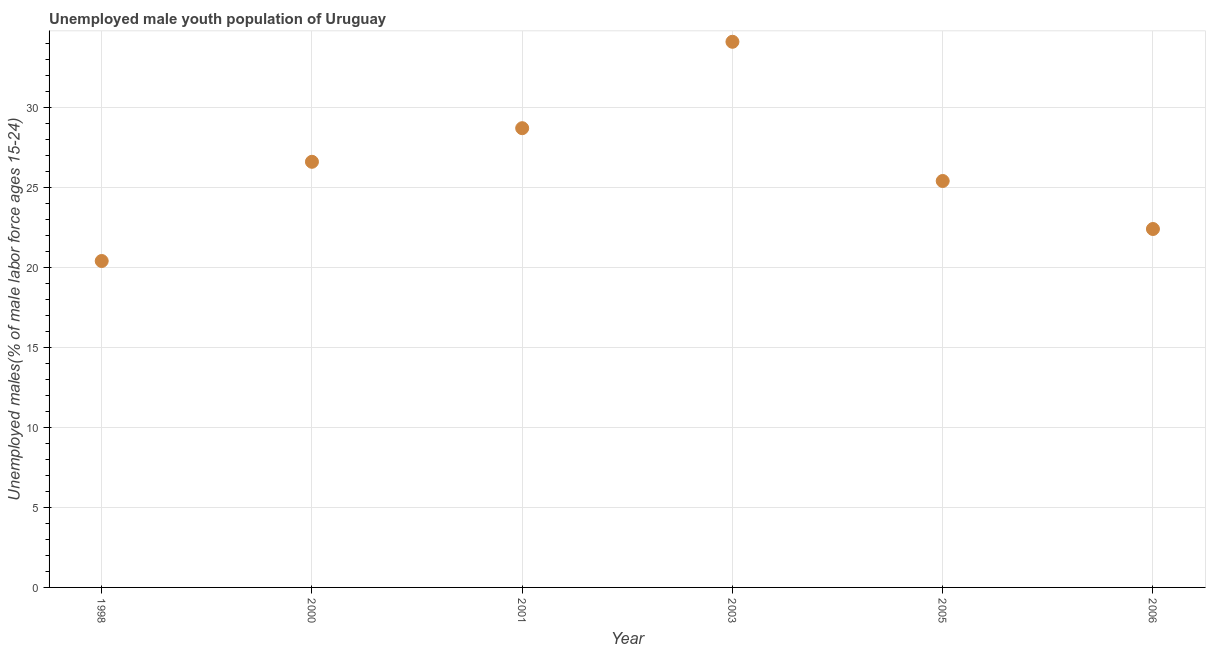What is the unemployed male youth in 2001?
Give a very brief answer. 28.7. Across all years, what is the maximum unemployed male youth?
Give a very brief answer. 34.1. Across all years, what is the minimum unemployed male youth?
Make the answer very short. 20.4. In which year was the unemployed male youth maximum?
Give a very brief answer. 2003. In which year was the unemployed male youth minimum?
Keep it short and to the point. 1998. What is the sum of the unemployed male youth?
Provide a succinct answer. 157.6. What is the difference between the unemployed male youth in 1998 and 2001?
Make the answer very short. -8.3. What is the average unemployed male youth per year?
Your answer should be very brief. 26.27. What is the ratio of the unemployed male youth in 1998 to that in 2001?
Your answer should be very brief. 0.71. What is the difference between the highest and the second highest unemployed male youth?
Give a very brief answer. 5.4. What is the difference between the highest and the lowest unemployed male youth?
Your answer should be very brief. 13.7. Does the unemployed male youth monotonically increase over the years?
Give a very brief answer. No. How many dotlines are there?
Make the answer very short. 1. How many years are there in the graph?
Your answer should be very brief. 6. Does the graph contain grids?
Keep it short and to the point. Yes. What is the title of the graph?
Provide a short and direct response. Unemployed male youth population of Uruguay. What is the label or title of the Y-axis?
Provide a succinct answer. Unemployed males(% of male labor force ages 15-24). What is the Unemployed males(% of male labor force ages 15-24) in 1998?
Keep it short and to the point. 20.4. What is the Unemployed males(% of male labor force ages 15-24) in 2000?
Provide a short and direct response. 26.6. What is the Unemployed males(% of male labor force ages 15-24) in 2001?
Provide a short and direct response. 28.7. What is the Unemployed males(% of male labor force ages 15-24) in 2003?
Provide a succinct answer. 34.1. What is the Unemployed males(% of male labor force ages 15-24) in 2005?
Your response must be concise. 25.4. What is the Unemployed males(% of male labor force ages 15-24) in 2006?
Your answer should be very brief. 22.4. What is the difference between the Unemployed males(% of male labor force ages 15-24) in 1998 and 2000?
Provide a short and direct response. -6.2. What is the difference between the Unemployed males(% of male labor force ages 15-24) in 1998 and 2003?
Offer a very short reply. -13.7. What is the difference between the Unemployed males(% of male labor force ages 15-24) in 1998 and 2005?
Provide a short and direct response. -5. What is the difference between the Unemployed males(% of male labor force ages 15-24) in 1998 and 2006?
Your answer should be compact. -2. What is the difference between the Unemployed males(% of male labor force ages 15-24) in 2000 and 2003?
Ensure brevity in your answer.  -7.5. What is the difference between the Unemployed males(% of male labor force ages 15-24) in 2000 and 2005?
Ensure brevity in your answer.  1.2. What is the difference between the Unemployed males(% of male labor force ages 15-24) in 2000 and 2006?
Give a very brief answer. 4.2. What is the difference between the Unemployed males(% of male labor force ages 15-24) in 2001 and 2003?
Ensure brevity in your answer.  -5.4. What is the difference between the Unemployed males(% of male labor force ages 15-24) in 2001 and 2005?
Give a very brief answer. 3.3. What is the difference between the Unemployed males(% of male labor force ages 15-24) in 2001 and 2006?
Give a very brief answer. 6.3. What is the difference between the Unemployed males(% of male labor force ages 15-24) in 2005 and 2006?
Provide a short and direct response. 3. What is the ratio of the Unemployed males(% of male labor force ages 15-24) in 1998 to that in 2000?
Your response must be concise. 0.77. What is the ratio of the Unemployed males(% of male labor force ages 15-24) in 1998 to that in 2001?
Make the answer very short. 0.71. What is the ratio of the Unemployed males(% of male labor force ages 15-24) in 1998 to that in 2003?
Your answer should be compact. 0.6. What is the ratio of the Unemployed males(% of male labor force ages 15-24) in 1998 to that in 2005?
Provide a short and direct response. 0.8. What is the ratio of the Unemployed males(% of male labor force ages 15-24) in 1998 to that in 2006?
Your response must be concise. 0.91. What is the ratio of the Unemployed males(% of male labor force ages 15-24) in 2000 to that in 2001?
Provide a short and direct response. 0.93. What is the ratio of the Unemployed males(% of male labor force ages 15-24) in 2000 to that in 2003?
Your response must be concise. 0.78. What is the ratio of the Unemployed males(% of male labor force ages 15-24) in 2000 to that in 2005?
Offer a very short reply. 1.05. What is the ratio of the Unemployed males(% of male labor force ages 15-24) in 2000 to that in 2006?
Make the answer very short. 1.19. What is the ratio of the Unemployed males(% of male labor force ages 15-24) in 2001 to that in 2003?
Offer a very short reply. 0.84. What is the ratio of the Unemployed males(% of male labor force ages 15-24) in 2001 to that in 2005?
Provide a succinct answer. 1.13. What is the ratio of the Unemployed males(% of male labor force ages 15-24) in 2001 to that in 2006?
Ensure brevity in your answer.  1.28. What is the ratio of the Unemployed males(% of male labor force ages 15-24) in 2003 to that in 2005?
Your answer should be very brief. 1.34. What is the ratio of the Unemployed males(% of male labor force ages 15-24) in 2003 to that in 2006?
Offer a terse response. 1.52. What is the ratio of the Unemployed males(% of male labor force ages 15-24) in 2005 to that in 2006?
Keep it short and to the point. 1.13. 